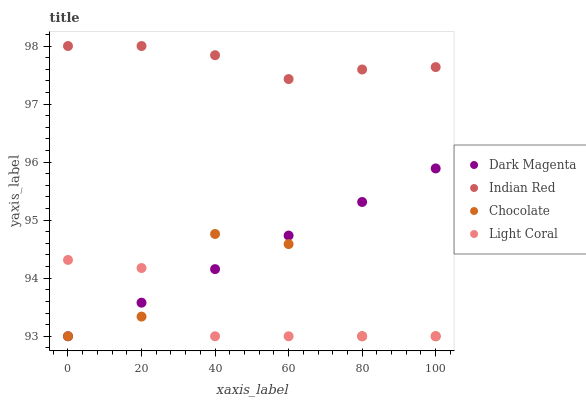Does Light Coral have the minimum area under the curve?
Answer yes or no. Yes. Does Indian Red have the maximum area under the curve?
Answer yes or no. Yes. Does Dark Magenta have the minimum area under the curve?
Answer yes or no. No. Does Dark Magenta have the maximum area under the curve?
Answer yes or no. No. Is Dark Magenta the smoothest?
Answer yes or no. Yes. Is Chocolate the roughest?
Answer yes or no. Yes. Is Indian Red the smoothest?
Answer yes or no. No. Is Indian Red the roughest?
Answer yes or no. No. Does Light Coral have the lowest value?
Answer yes or no. Yes. Does Indian Red have the lowest value?
Answer yes or no. No. Does Indian Red have the highest value?
Answer yes or no. Yes. Does Dark Magenta have the highest value?
Answer yes or no. No. Is Dark Magenta less than Indian Red?
Answer yes or no. Yes. Is Indian Red greater than Light Coral?
Answer yes or no. Yes. Does Light Coral intersect Dark Magenta?
Answer yes or no. Yes. Is Light Coral less than Dark Magenta?
Answer yes or no. No. Is Light Coral greater than Dark Magenta?
Answer yes or no. No. Does Dark Magenta intersect Indian Red?
Answer yes or no. No. 